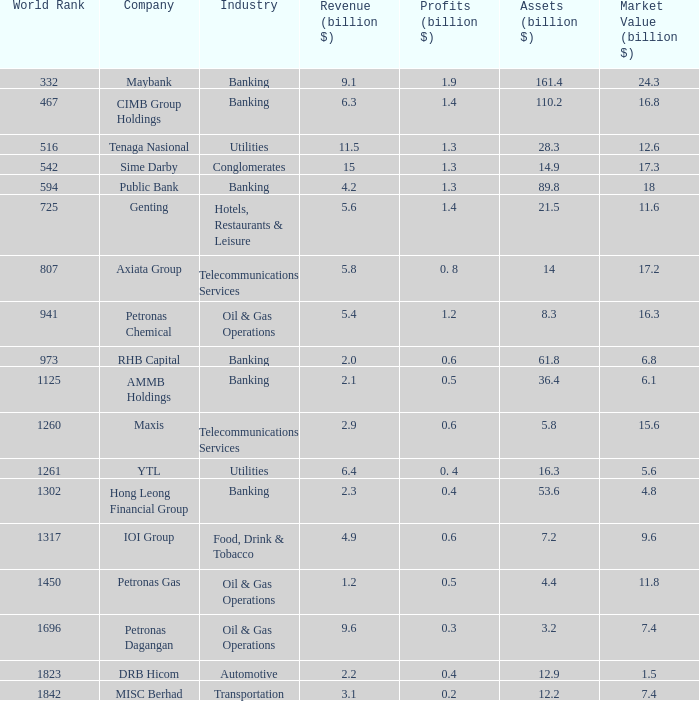1 earnings. Banking. 